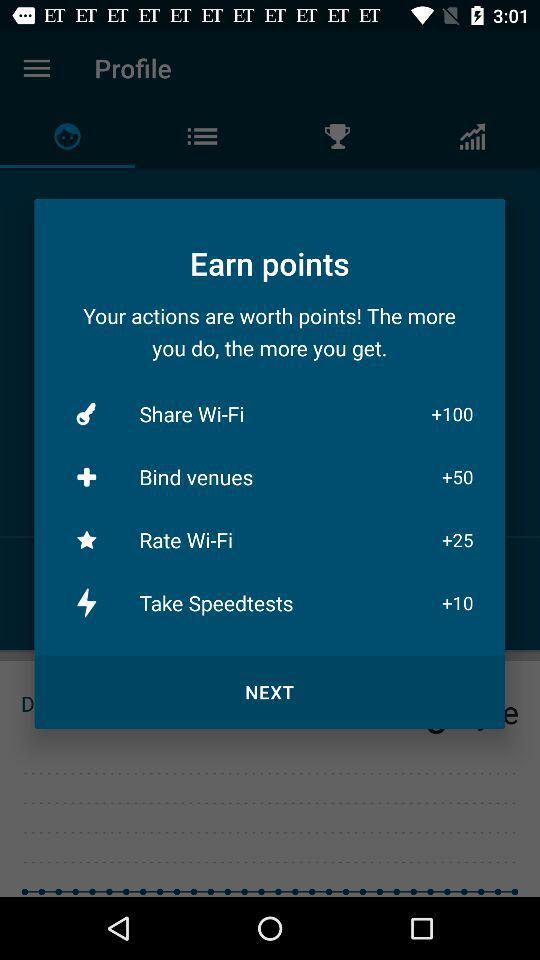How many points can I earn by taking speed tests? You can earn 10 points by taking speed tests. 